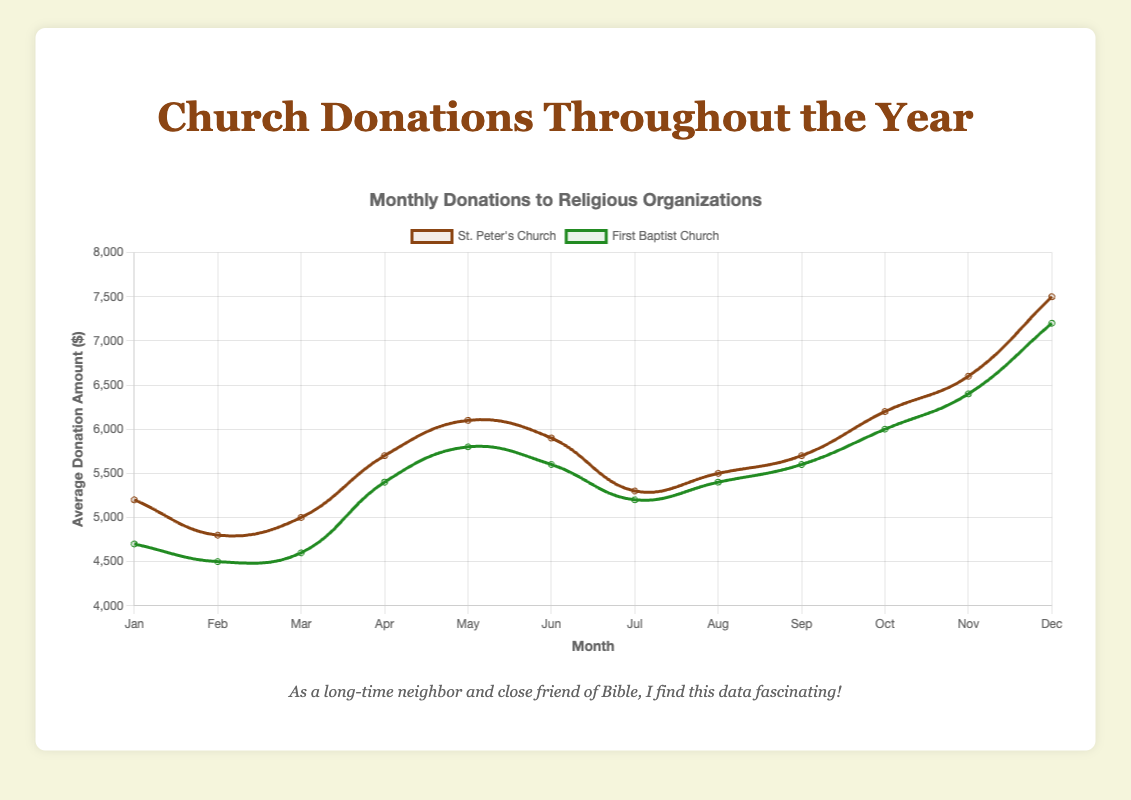Which month has the highest average donation for St. Peter's Church? From the plot, the highest point on the curve for St. Peter's Church occurs in December. This is where the donations peak compared to other months.
Answer: December Which church has higher average donations in March? By comparing the two data series for March, St. Peter's Church has an average donation of $5,000 while First Baptist Church has $4,600. So, St. Peter's Church has higher average donations.
Answer: St. Peter's Church What is the average donation amount for St. Peter's Church in the first quarter (January to March)? Adding the average donations in January ($5,200), February ($4,800), and March ($5,000) gives a total of $15,000. Dividing this by 3 months gives an average of $5,000.
Answer: $5,000 Which month shows the smallest difference in average donations between the two churches? By visually comparing the gap between the curves each month, the smallest difference occurs in March where the gap between $5,000 for St. Peter's Church and $4,600 for First Baptist Church is $400.
Answer: March By how much does the average donation amount for First Baptist Church increase from June to December? The average donation in June is $5,600 and in December is $7,200. The difference is $7,200 - $5,600 = $1,600.
Answer: $1,600 Which church shows more fluctuation in donations throughout the year? By observing the jaggedness and range of the two curves, St. Peter's Church shows more fluctuation since its curve has more pronounced peaks and valleys compared to First Baptist Church.
Answer: St. Peter's Church What is the total average donation amount for both churches combined in November? St. Peter's Church has $6,600 and First Baptist Church has $6,400 in November. Adding these gives a total of $6,600 + $6,400 = $13,000.
Answer: $13,000 In which month do donations to St. Peter's Church surpass those to First Baptist Church by the largest amount? The largest vertical gap between the two lines on the chart is in December. St. Peter's Church has $7,500 and First Baptist Church has $7,200, making a difference of $300.
Answer: December What visual pattern do you notice in the donations for both churches throughout the year? Both churches show an upward trend in donations towards the end of the year, peaking in December, indicating a seasonal increase.
Answer: Seasonal increase towards December Are there any months where the average donation amount is equal for both churches? Visually checking each month, the lines for the two churches do not intersect at any point, indicating no months where donation amounts are equal.
Answer: No 